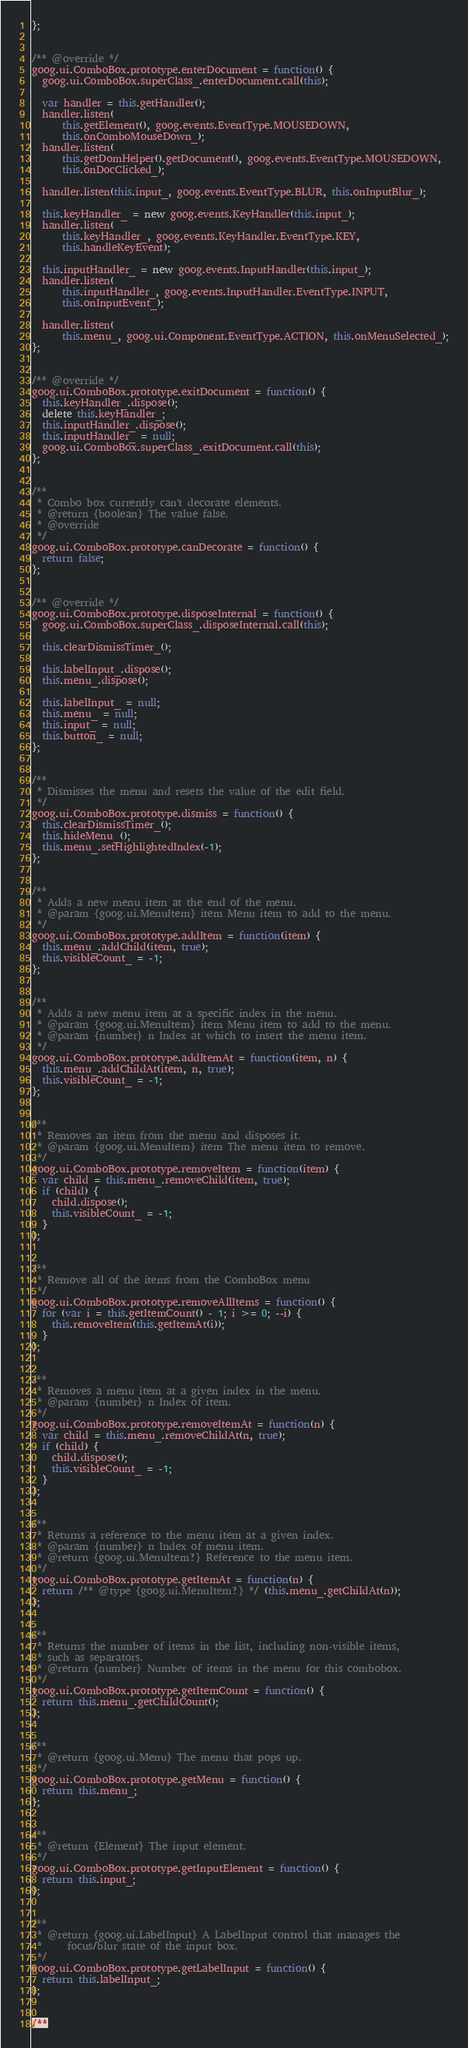<code> <loc_0><loc_0><loc_500><loc_500><_JavaScript_>};


/** @override */
goog.ui.ComboBox.prototype.enterDocument = function() {
  goog.ui.ComboBox.superClass_.enterDocument.call(this);

  var handler = this.getHandler();
  handler.listen(
      this.getElement(), goog.events.EventType.MOUSEDOWN,
      this.onComboMouseDown_);
  handler.listen(
      this.getDomHelper().getDocument(), goog.events.EventType.MOUSEDOWN,
      this.onDocClicked_);

  handler.listen(this.input_, goog.events.EventType.BLUR, this.onInputBlur_);

  this.keyHandler_ = new goog.events.KeyHandler(this.input_);
  handler.listen(
      this.keyHandler_, goog.events.KeyHandler.EventType.KEY,
      this.handleKeyEvent);

  this.inputHandler_ = new goog.events.InputHandler(this.input_);
  handler.listen(
      this.inputHandler_, goog.events.InputHandler.EventType.INPUT,
      this.onInputEvent_);

  handler.listen(
      this.menu_, goog.ui.Component.EventType.ACTION, this.onMenuSelected_);
};


/** @override */
goog.ui.ComboBox.prototype.exitDocument = function() {
  this.keyHandler_.dispose();
  delete this.keyHandler_;
  this.inputHandler_.dispose();
  this.inputHandler_ = null;
  goog.ui.ComboBox.superClass_.exitDocument.call(this);
};


/**
 * Combo box currently can't decorate elements.
 * @return {boolean} The value false.
 * @override
 */
goog.ui.ComboBox.prototype.canDecorate = function() {
  return false;
};


/** @override */
goog.ui.ComboBox.prototype.disposeInternal = function() {
  goog.ui.ComboBox.superClass_.disposeInternal.call(this);

  this.clearDismissTimer_();

  this.labelInput_.dispose();
  this.menu_.dispose();

  this.labelInput_ = null;
  this.menu_ = null;
  this.input_ = null;
  this.button_ = null;
};


/**
 * Dismisses the menu and resets the value of the edit field.
 */
goog.ui.ComboBox.prototype.dismiss = function() {
  this.clearDismissTimer_();
  this.hideMenu_();
  this.menu_.setHighlightedIndex(-1);
};


/**
 * Adds a new menu item at the end of the menu.
 * @param {goog.ui.MenuItem} item Menu item to add to the menu.
 */
goog.ui.ComboBox.prototype.addItem = function(item) {
  this.menu_.addChild(item, true);
  this.visibleCount_ = -1;
};


/**
 * Adds a new menu item at a specific index in the menu.
 * @param {goog.ui.MenuItem} item Menu item to add to the menu.
 * @param {number} n Index at which to insert the menu item.
 */
goog.ui.ComboBox.prototype.addItemAt = function(item, n) {
  this.menu_.addChildAt(item, n, true);
  this.visibleCount_ = -1;
};


/**
 * Removes an item from the menu and disposes it.
 * @param {goog.ui.MenuItem} item The menu item to remove.
 */
goog.ui.ComboBox.prototype.removeItem = function(item) {
  var child = this.menu_.removeChild(item, true);
  if (child) {
    child.dispose();
    this.visibleCount_ = -1;
  }
};


/**
 * Remove all of the items from the ComboBox menu
 */
goog.ui.ComboBox.prototype.removeAllItems = function() {
  for (var i = this.getItemCount() - 1; i >= 0; --i) {
    this.removeItem(this.getItemAt(i));
  }
};


/**
 * Removes a menu item at a given index in the menu.
 * @param {number} n Index of item.
 */
goog.ui.ComboBox.prototype.removeItemAt = function(n) {
  var child = this.menu_.removeChildAt(n, true);
  if (child) {
    child.dispose();
    this.visibleCount_ = -1;
  }
};


/**
 * Returns a reference to the menu item at a given index.
 * @param {number} n Index of menu item.
 * @return {goog.ui.MenuItem?} Reference to the menu item.
 */
goog.ui.ComboBox.prototype.getItemAt = function(n) {
  return /** @type {goog.ui.MenuItem?} */ (this.menu_.getChildAt(n));
};


/**
 * Returns the number of items in the list, including non-visible items,
 * such as separators.
 * @return {number} Number of items in the menu for this combobox.
 */
goog.ui.ComboBox.prototype.getItemCount = function() {
  return this.menu_.getChildCount();
};


/**
 * @return {goog.ui.Menu} The menu that pops up.
 */
goog.ui.ComboBox.prototype.getMenu = function() {
  return this.menu_;
};


/**
 * @return {Element} The input element.
 */
goog.ui.ComboBox.prototype.getInputElement = function() {
  return this.input_;
};


/**
 * @return {goog.ui.LabelInput} A LabelInput control that manages the
 *     focus/blur state of the input box.
 */
goog.ui.ComboBox.prototype.getLabelInput = function() {
  return this.labelInput_;
};


/**</code> 